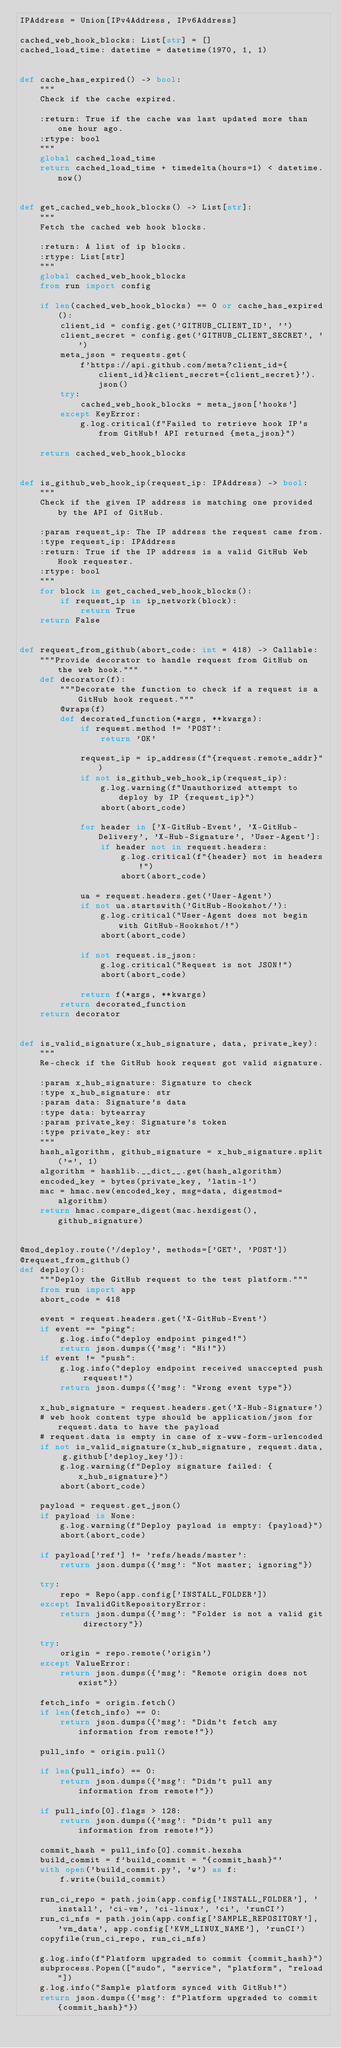Convert code to text. <code><loc_0><loc_0><loc_500><loc_500><_Python_>IPAddress = Union[IPv4Address, IPv6Address]

cached_web_hook_blocks: List[str] = []
cached_load_time: datetime = datetime(1970, 1, 1)


def cache_has_expired() -> bool:
    """
    Check if the cache expired.

    :return: True if the cache was last updated more than one hour ago.
    :rtype: bool
    """
    global cached_load_time
    return cached_load_time + timedelta(hours=1) < datetime.now()


def get_cached_web_hook_blocks() -> List[str]:
    """
    Fetch the cached web hook blocks.

    :return: A list of ip blocks.
    :rtype: List[str]
    """
    global cached_web_hook_blocks
    from run import config

    if len(cached_web_hook_blocks) == 0 or cache_has_expired():
        client_id = config.get('GITHUB_CLIENT_ID', '')
        client_secret = config.get('GITHUB_CLIENT_SECRET', '')
        meta_json = requests.get(
            f'https://api.github.com/meta?client_id={client_id}&client_secret={client_secret}').json()
        try:
            cached_web_hook_blocks = meta_json['hooks']
        except KeyError:
            g.log.critical(f"Failed to retrieve hook IP's from GitHub! API returned {meta_json}")

    return cached_web_hook_blocks


def is_github_web_hook_ip(request_ip: IPAddress) -> bool:
    """
    Check if the given IP address is matching one provided by the API of GitHub.

    :param request_ip: The IP address the request came from.
    :type request_ip: IPAddress
    :return: True if the IP address is a valid GitHub Web Hook requester.
    :rtype: bool
    """
    for block in get_cached_web_hook_blocks():
        if request_ip in ip_network(block):
            return True
    return False


def request_from_github(abort_code: int = 418) -> Callable:
    """Provide decorator to handle request from GitHub on the web hook."""
    def decorator(f):
        """Decorate the function to check if a request is a GitHub hook request."""
        @wraps(f)
        def decorated_function(*args, **kwargs):
            if request.method != 'POST':
                return 'OK'

            request_ip = ip_address(f"{request.remote_addr}")
            if not is_github_web_hook_ip(request_ip):
                g.log.warning(f"Unauthorized attempt to deploy by IP {request_ip}")
                abort(abort_code)

            for header in ['X-GitHub-Event', 'X-GitHub-Delivery', 'X-Hub-Signature', 'User-Agent']:
                if header not in request.headers:
                    g.log.critical(f"{header} not in headers!")
                    abort(abort_code)

            ua = request.headers.get('User-Agent')
            if not ua.startswith('GitHub-Hookshot/'):
                g.log.critical("User-Agent does not begin with GitHub-Hookshot/!")
                abort(abort_code)

            if not request.is_json:
                g.log.critical("Request is not JSON!")
                abort(abort_code)

            return f(*args, **kwargs)
        return decorated_function
    return decorator


def is_valid_signature(x_hub_signature, data, private_key):
    """
    Re-check if the GitHub hook request got valid signature.

    :param x_hub_signature: Signature to check
    :type x_hub_signature: str
    :param data: Signature's data
    :type data: bytearray
    :param private_key: Signature's token
    :type private_key: str
    """
    hash_algorithm, github_signature = x_hub_signature.split('=', 1)
    algorithm = hashlib.__dict__.get(hash_algorithm)
    encoded_key = bytes(private_key, 'latin-1')
    mac = hmac.new(encoded_key, msg=data, digestmod=algorithm)
    return hmac.compare_digest(mac.hexdigest(), github_signature)


@mod_deploy.route('/deploy', methods=['GET', 'POST'])
@request_from_github()
def deploy():
    """Deploy the GitHub request to the test platform."""
    from run import app
    abort_code = 418

    event = request.headers.get('X-GitHub-Event')
    if event == "ping":
        g.log.info("deploy endpoint pinged!")
        return json.dumps({'msg': "Hi!"})
    if event != "push":
        g.log.info("deploy endpoint received unaccepted push request!")
        return json.dumps({'msg': "Wrong event type"})

    x_hub_signature = request.headers.get('X-Hub-Signature')
    # web hook content type should be application/json for request.data to have the payload
    # request.data is empty in case of x-www-form-urlencoded
    if not is_valid_signature(x_hub_signature, request.data, g.github['deploy_key']):
        g.log.warning(f"Deploy signature failed: {x_hub_signature}")
        abort(abort_code)

    payload = request.get_json()
    if payload is None:
        g.log.warning(f"Deploy payload is empty: {payload}")
        abort(abort_code)

    if payload['ref'] != 'refs/heads/master':
        return json.dumps({'msg': "Not master; ignoring"})

    try:
        repo = Repo(app.config['INSTALL_FOLDER'])
    except InvalidGitRepositoryError:
        return json.dumps({'msg': "Folder is not a valid git directory"})

    try:
        origin = repo.remote('origin')
    except ValueError:
        return json.dumps({'msg': "Remote origin does not exist"})

    fetch_info = origin.fetch()
    if len(fetch_info) == 0:
        return json.dumps({'msg': "Didn't fetch any information from remote!"})

    pull_info = origin.pull()

    if len(pull_info) == 0:
        return json.dumps({'msg': "Didn't pull any information from remote!"})

    if pull_info[0].flags > 128:
        return json.dumps({'msg': "Didn't pull any information from remote!"})

    commit_hash = pull_info[0].commit.hexsha
    build_commit = f'build_commit = "{commit_hash}"'
    with open('build_commit.py', 'w') as f:
        f.write(build_commit)

    run_ci_repo = path.join(app.config['INSTALL_FOLDER'], 'install', 'ci-vm', 'ci-linux', 'ci', 'runCI')
    run_ci_nfs = path.join(app.config['SAMPLE_REPOSITORY'], 'vm_data', app.config['KVM_LINUX_NAME'], 'runCI')
    copyfile(run_ci_repo, run_ci_nfs)

    g.log.info(f"Platform upgraded to commit {commit_hash}")
    subprocess.Popen(["sudo", "service", "platform", "reload"])
    g.log.info("Sample platform synced with GitHub!")
    return json.dumps({'msg': f"Platform upgraded to commit {commit_hash}"})
</code> 